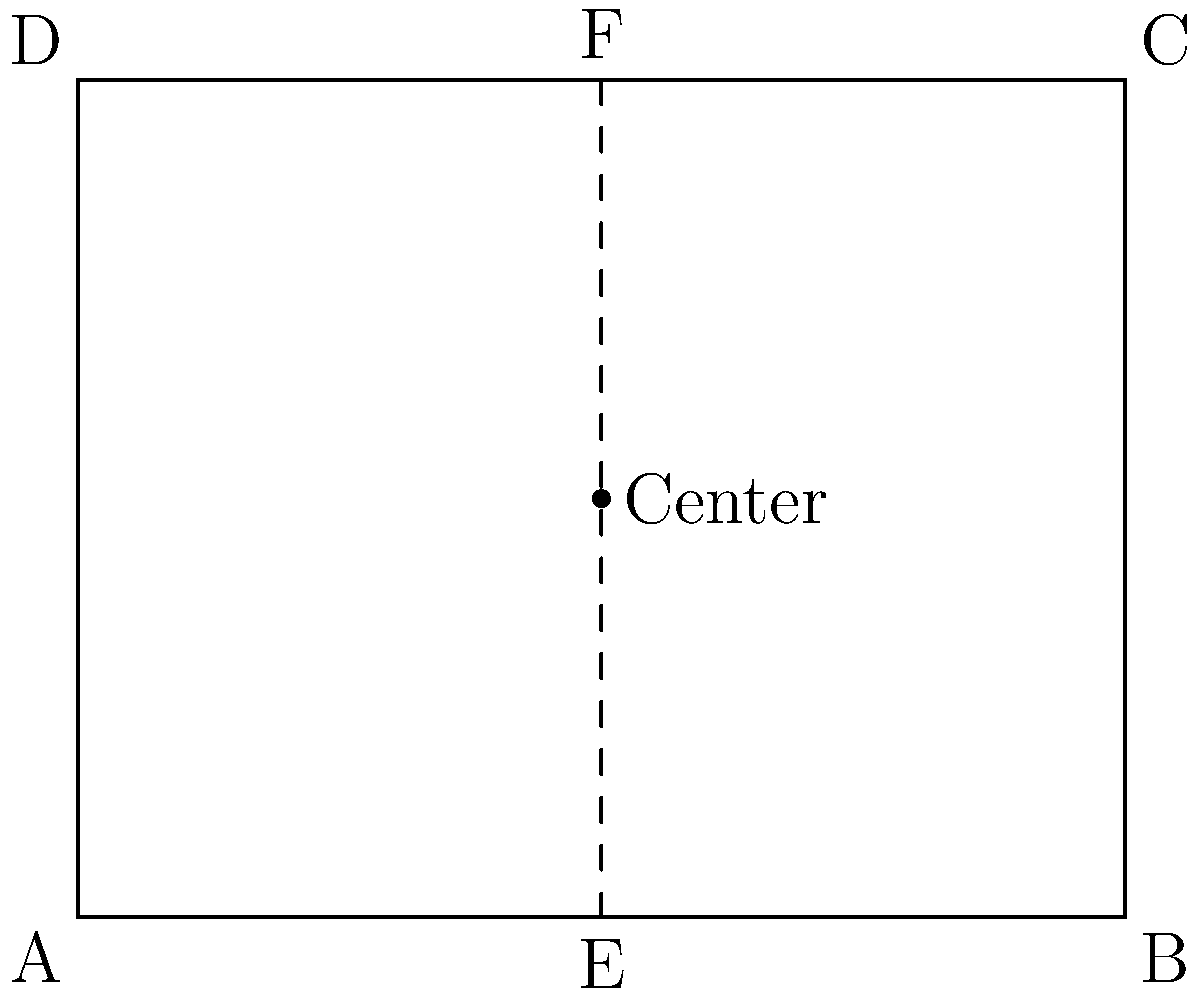In the design of a historical printing press shown above, the rectangular frame ABCD represents the main structure. If line EF represents the axis of symmetry, and the center point is located at (5,4), what is the ratio of the area of triangle AEF to the total area of the rectangle ABCD? To solve this problem, let's follow these steps:

1. Determine the dimensions of the rectangle:
   Width = 10 units
   Height = 8 units

2. Calculate the area of rectangle ABCD:
   Area_ABCD = 10 * 8 = 80 square units

3. Find the coordinates of point F:
   F is on the symmetry line at the top of the rectangle, so its coordinates are (5,8)

4. Calculate the area of triangle AEF:
   Base (AE) = 5 units
   Height (from A to F) = 8 units
   Area_AEF = (1/2) * base * height = (1/2) * 5 * 8 = 20 square units

5. Calculate the ratio of the area of triangle AEF to the area of rectangle ABCD:
   Ratio = Area_AEF / Area_ABCD = 20 / 80 = 1 / 4

Therefore, the ratio of the area of triangle AEF to the total area of rectangle ABCD is 1:4 or 1/4.
Answer: 1/4 